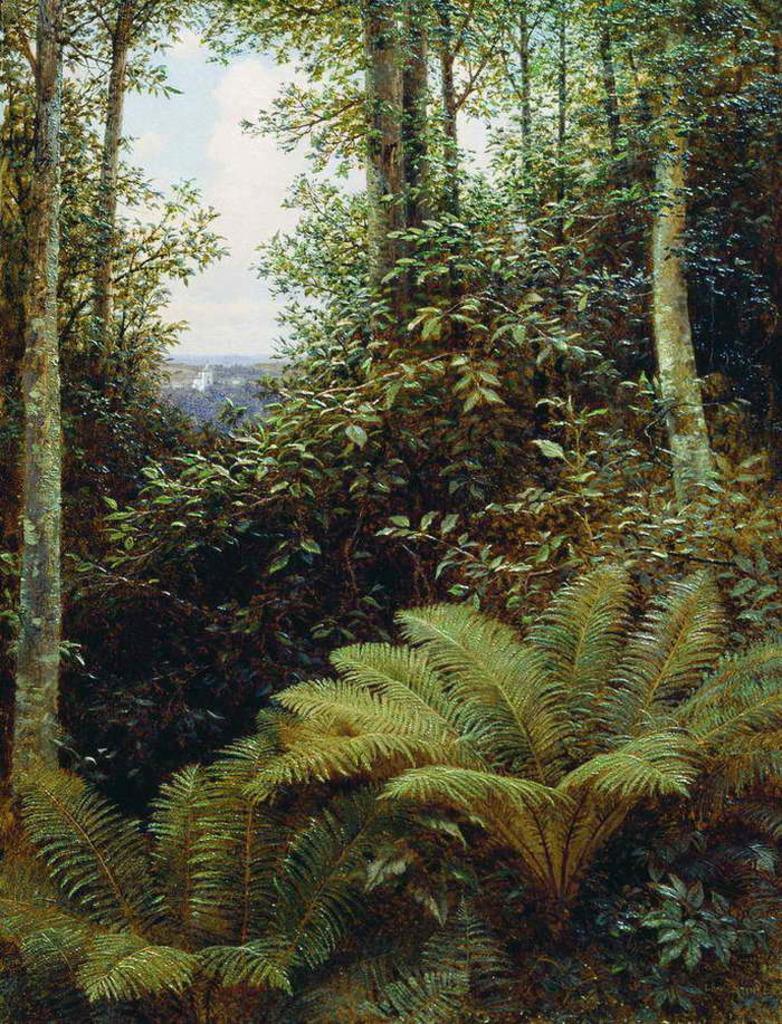Can you describe this image briefly? In this image there are few plants and trees on the land. Behind it there is sky with some clouds. 